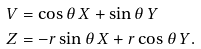Convert formula to latex. <formula><loc_0><loc_0><loc_500><loc_500>V & = \cos \theta \, X + \sin \theta \, Y \\ Z & = - r \sin \theta \, X + r \cos \theta \, Y .</formula> 